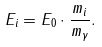Convert formula to latex. <formula><loc_0><loc_0><loc_500><loc_500>E _ { i } = E _ { 0 } \cdot \frac { m _ { i } } { m _ { \gamma } } .</formula> 